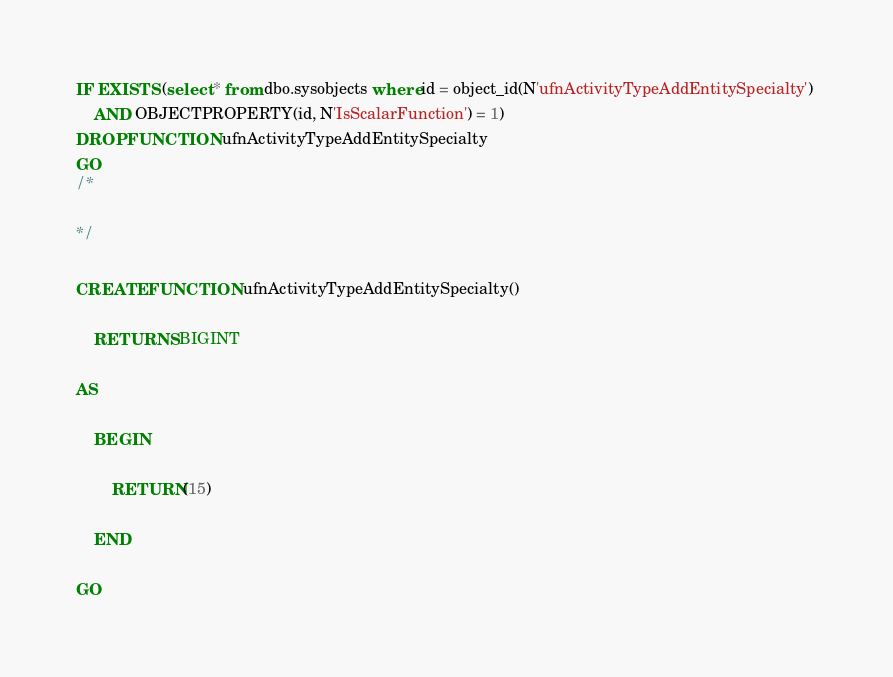<code> <loc_0><loc_0><loc_500><loc_500><_SQL_>IF EXISTS (select * from dbo.sysobjects where id = object_id(N'ufnActivityTypeAddEntitySpecialty') 
	AND OBJECTPROPERTY(id, N'IsScalarFunction') = 1)
DROP FUNCTION ufnActivityTypeAddEntitySpecialty
GO
/*
	
*/

CREATE FUNCTION ufnActivityTypeAddEntitySpecialty()

	RETURNS BIGINT

AS

	BEGIN
		
		RETURN(15)

	END

GO</code> 